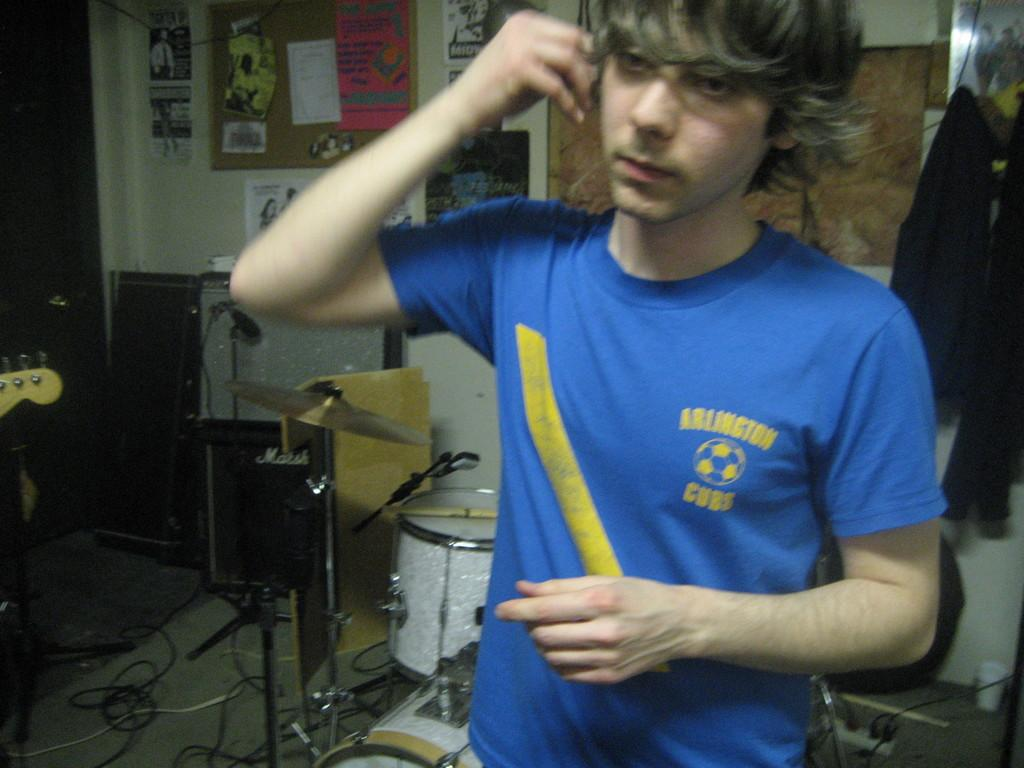<image>
Provide a brief description of the given image. A boy by a drum set is holding an earbud up to his ear and wearing a blue Arlington Cubs shirt. 